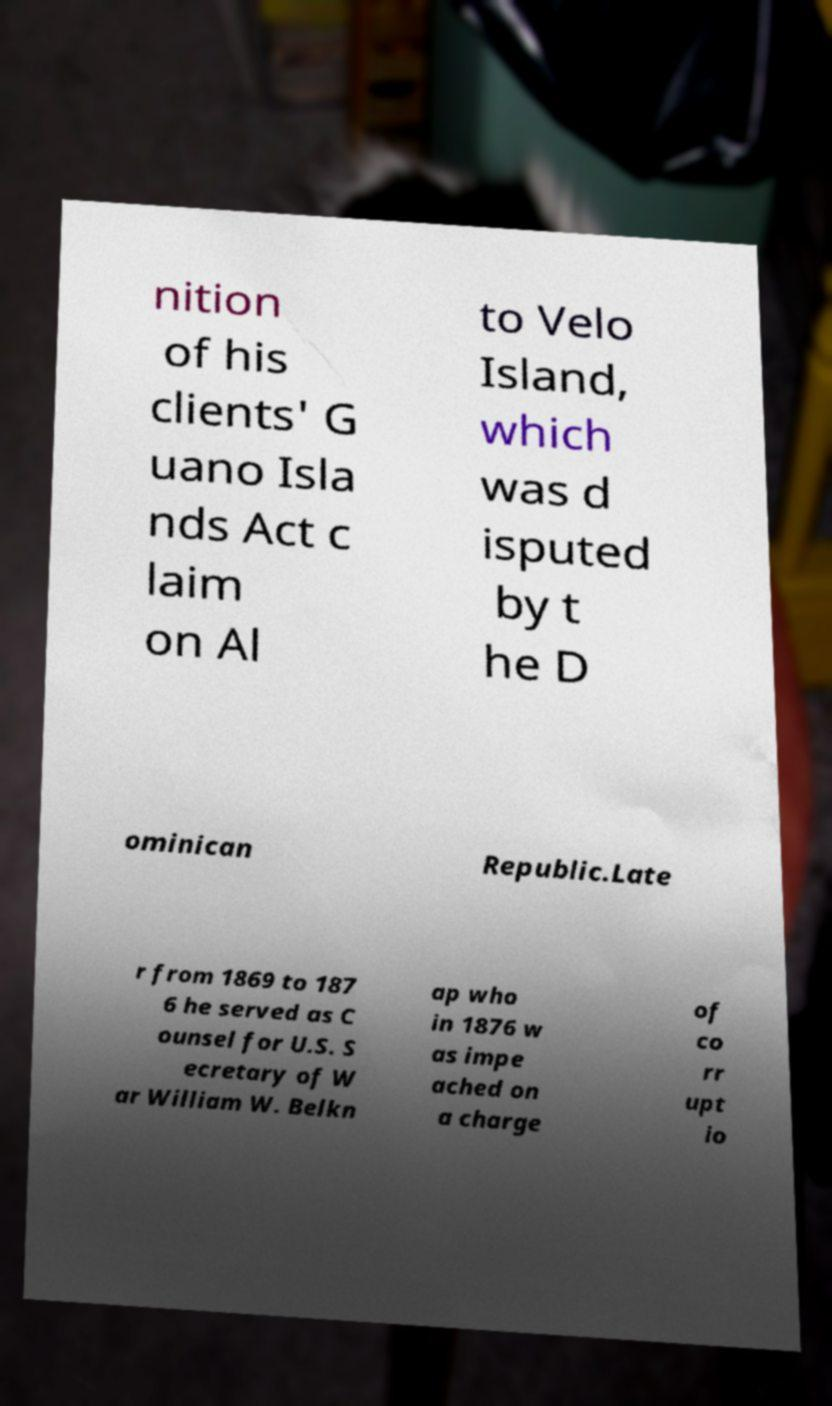Can you accurately transcribe the text from the provided image for me? nition of his clients' G uano Isla nds Act c laim on Al to Velo Island, which was d isputed by t he D ominican Republic.Late r from 1869 to 187 6 he served as C ounsel for U.S. S ecretary of W ar William W. Belkn ap who in 1876 w as impe ached on a charge of co rr upt io 